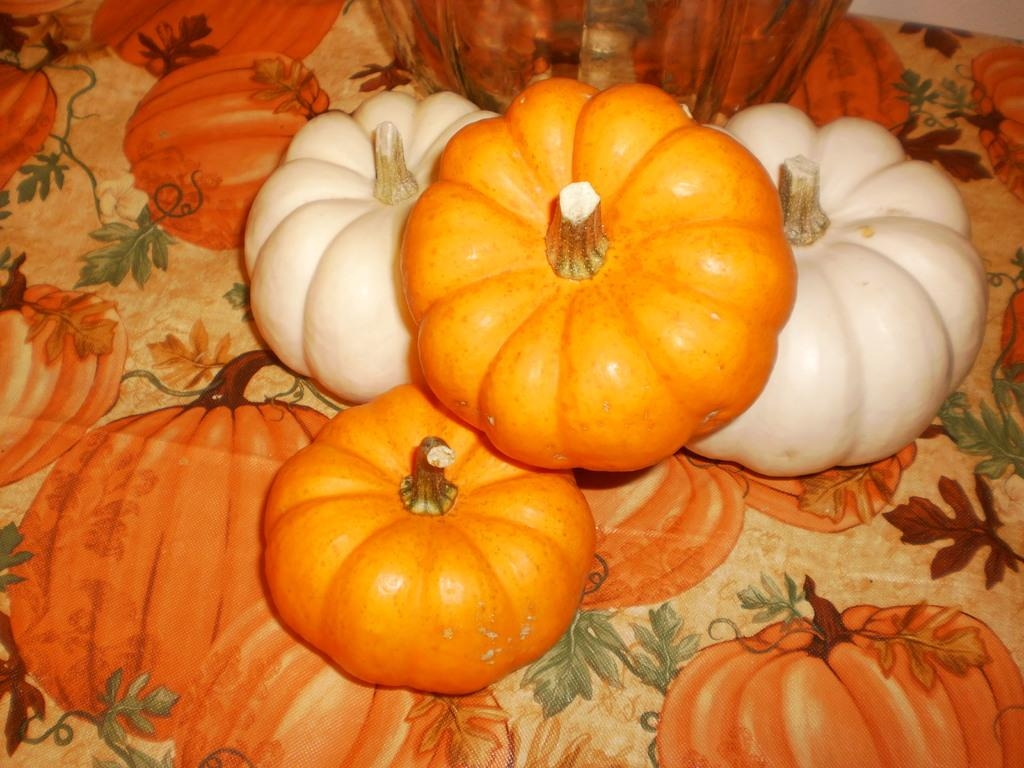What type of objects are present in the image? There are pumpkins in the image. Where are the pumpkins located? The pumpkins are placed on a table. What type of bear can be seen interacting with the pumpkins in the image? There is no bear present in the image; it only features pumpkins placed on a table. 